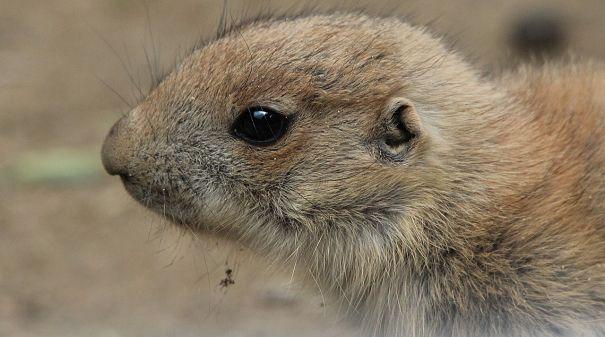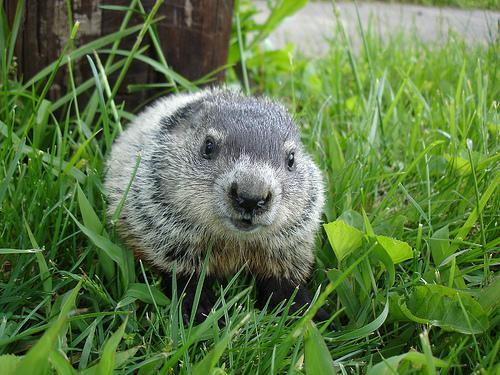The first image is the image on the left, the second image is the image on the right. Considering the images on both sides, is "The left image includes a right-facing marmot with its front paws propped up on something." valid? Answer yes or no. No. The first image is the image on the left, the second image is the image on the right. Considering the images on both sides, is "There is one image that does not include green vegetation in the background." valid? Answer yes or no. Yes. 